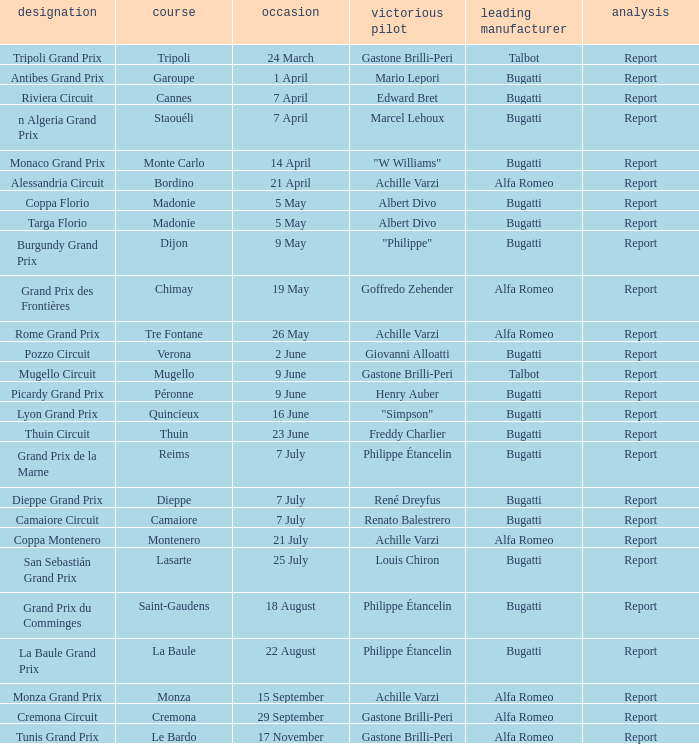What Circuit has a Date of 25 july? Lasarte. 